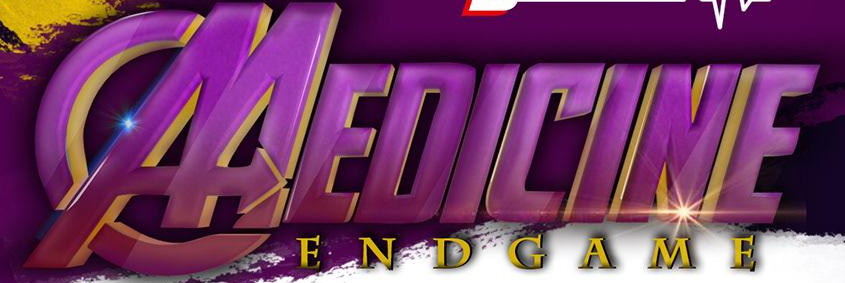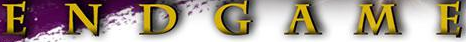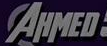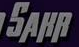Read the text from these images in sequence, separated by a semicolon. MEDICINE; ENDGAME; AHMED; SAHR 